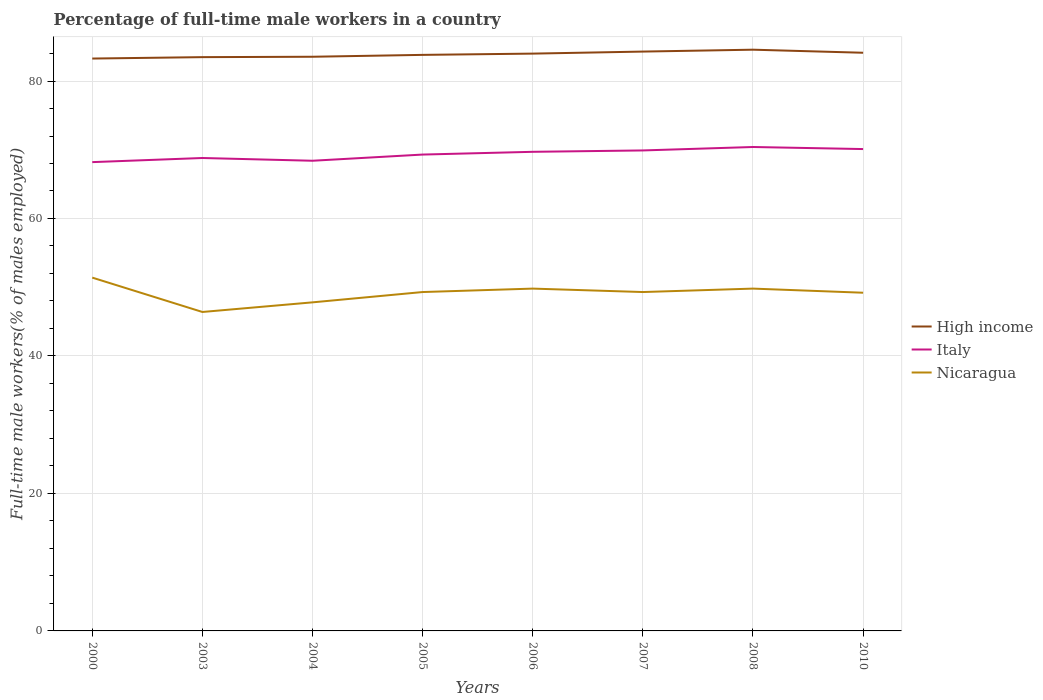Is the number of lines equal to the number of legend labels?
Provide a succinct answer. Yes. Across all years, what is the maximum percentage of full-time male workers in High income?
Give a very brief answer. 83.27. What is the total percentage of full-time male workers in Italy in the graph?
Ensure brevity in your answer.  -1.1. What is the difference between the highest and the second highest percentage of full-time male workers in Italy?
Offer a very short reply. 2.2. Is the percentage of full-time male workers in Italy strictly greater than the percentage of full-time male workers in Nicaragua over the years?
Provide a short and direct response. No. What is the difference between two consecutive major ticks on the Y-axis?
Your response must be concise. 20. Does the graph contain any zero values?
Provide a succinct answer. No. Does the graph contain grids?
Make the answer very short. Yes. How many legend labels are there?
Ensure brevity in your answer.  3. How are the legend labels stacked?
Your response must be concise. Vertical. What is the title of the graph?
Your answer should be very brief. Percentage of full-time male workers in a country. What is the label or title of the Y-axis?
Make the answer very short. Full-time male workers(% of males employed). What is the Full-time male workers(% of males employed) of High income in 2000?
Keep it short and to the point. 83.27. What is the Full-time male workers(% of males employed) in Italy in 2000?
Provide a succinct answer. 68.2. What is the Full-time male workers(% of males employed) in Nicaragua in 2000?
Give a very brief answer. 51.4. What is the Full-time male workers(% of males employed) of High income in 2003?
Ensure brevity in your answer.  83.47. What is the Full-time male workers(% of males employed) of Italy in 2003?
Your response must be concise. 68.8. What is the Full-time male workers(% of males employed) of Nicaragua in 2003?
Your response must be concise. 46.4. What is the Full-time male workers(% of males employed) of High income in 2004?
Ensure brevity in your answer.  83.53. What is the Full-time male workers(% of males employed) of Italy in 2004?
Offer a terse response. 68.4. What is the Full-time male workers(% of males employed) of Nicaragua in 2004?
Offer a very short reply. 47.8. What is the Full-time male workers(% of males employed) of High income in 2005?
Ensure brevity in your answer.  83.8. What is the Full-time male workers(% of males employed) in Italy in 2005?
Give a very brief answer. 69.3. What is the Full-time male workers(% of males employed) in Nicaragua in 2005?
Ensure brevity in your answer.  49.3. What is the Full-time male workers(% of males employed) in High income in 2006?
Offer a very short reply. 83.99. What is the Full-time male workers(% of males employed) of Italy in 2006?
Your response must be concise. 69.7. What is the Full-time male workers(% of males employed) of Nicaragua in 2006?
Offer a very short reply. 49.8. What is the Full-time male workers(% of males employed) in High income in 2007?
Your answer should be very brief. 84.28. What is the Full-time male workers(% of males employed) of Italy in 2007?
Keep it short and to the point. 69.9. What is the Full-time male workers(% of males employed) in Nicaragua in 2007?
Keep it short and to the point. 49.3. What is the Full-time male workers(% of males employed) in High income in 2008?
Give a very brief answer. 84.56. What is the Full-time male workers(% of males employed) of Italy in 2008?
Your response must be concise. 70.4. What is the Full-time male workers(% of males employed) in Nicaragua in 2008?
Provide a succinct answer. 49.8. What is the Full-time male workers(% of males employed) in High income in 2010?
Keep it short and to the point. 84.11. What is the Full-time male workers(% of males employed) of Italy in 2010?
Your answer should be very brief. 70.1. What is the Full-time male workers(% of males employed) in Nicaragua in 2010?
Ensure brevity in your answer.  49.2. Across all years, what is the maximum Full-time male workers(% of males employed) of High income?
Provide a short and direct response. 84.56. Across all years, what is the maximum Full-time male workers(% of males employed) of Italy?
Your response must be concise. 70.4. Across all years, what is the maximum Full-time male workers(% of males employed) in Nicaragua?
Provide a short and direct response. 51.4. Across all years, what is the minimum Full-time male workers(% of males employed) of High income?
Your answer should be very brief. 83.27. Across all years, what is the minimum Full-time male workers(% of males employed) of Italy?
Provide a succinct answer. 68.2. Across all years, what is the minimum Full-time male workers(% of males employed) of Nicaragua?
Offer a very short reply. 46.4. What is the total Full-time male workers(% of males employed) of High income in the graph?
Your answer should be compact. 671.01. What is the total Full-time male workers(% of males employed) of Italy in the graph?
Offer a terse response. 554.8. What is the total Full-time male workers(% of males employed) of Nicaragua in the graph?
Keep it short and to the point. 393. What is the difference between the Full-time male workers(% of males employed) in High income in 2000 and that in 2003?
Give a very brief answer. -0.2. What is the difference between the Full-time male workers(% of males employed) in High income in 2000 and that in 2004?
Ensure brevity in your answer.  -0.26. What is the difference between the Full-time male workers(% of males employed) in Italy in 2000 and that in 2004?
Your response must be concise. -0.2. What is the difference between the Full-time male workers(% of males employed) in Nicaragua in 2000 and that in 2004?
Your answer should be compact. 3.6. What is the difference between the Full-time male workers(% of males employed) of High income in 2000 and that in 2005?
Keep it short and to the point. -0.53. What is the difference between the Full-time male workers(% of males employed) in Italy in 2000 and that in 2005?
Your response must be concise. -1.1. What is the difference between the Full-time male workers(% of males employed) in Nicaragua in 2000 and that in 2005?
Offer a very short reply. 2.1. What is the difference between the Full-time male workers(% of males employed) of High income in 2000 and that in 2006?
Ensure brevity in your answer.  -0.72. What is the difference between the Full-time male workers(% of males employed) in Nicaragua in 2000 and that in 2006?
Offer a terse response. 1.6. What is the difference between the Full-time male workers(% of males employed) of High income in 2000 and that in 2007?
Your answer should be compact. -1.01. What is the difference between the Full-time male workers(% of males employed) of High income in 2000 and that in 2008?
Your answer should be very brief. -1.29. What is the difference between the Full-time male workers(% of males employed) in High income in 2000 and that in 2010?
Offer a terse response. -0.84. What is the difference between the Full-time male workers(% of males employed) of High income in 2003 and that in 2004?
Your answer should be compact. -0.06. What is the difference between the Full-time male workers(% of males employed) in Nicaragua in 2003 and that in 2004?
Provide a short and direct response. -1.4. What is the difference between the Full-time male workers(% of males employed) of High income in 2003 and that in 2005?
Your answer should be very brief. -0.33. What is the difference between the Full-time male workers(% of males employed) in Italy in 2003 and that in 2005?
Your answer should be compact. -0.5. What is the difference between the Full-time male workers(% of males employed) in Nicaragua in 2003 and that in 2005?
Your answer should be compact. -2.9. What is the difference between the Full-time male workers(% of males employed) in High income in 2003 and that in 2006?
Provide a short and direct response. -0.51. What is the difference between the Full-time male workers(% of males employed) in Italy in 2003 and that in 2006?
Your answer should be compact. -0.9. What is the difference between the Full-time male workers(% of males employed) of High income in 2003 and that in 2007?
Offer a very short reply. -0.81. What is the difference between the Full-time male workers(% of males employed) of Italy in 2003 and that in 2007?
Your response must be concise. -1.1. What is the difference between the Full-time male workers(% of males employed) in Nicaragua in 2003 and that in 2007?
Your answer should be compact. -2.9. What is the difference between the Full-time male workers(% of males employed) in High income in 2003 and that in 2008?
Ensure brevity in your answer.  -1.08. What is the difference between the Full-time male workers(% of males employed) in Italy in 2003 and that in 2008?
Your response must be concise. -1.6. What is the difference between the Full-time male workers(% of males employed) in High income in 2003 and that in 2010?
Your response must be concise. -0.64. What is the difference between the Full-time male workers(% of males employed) of Italy in 2003 and that in 2010?
Your answer should be very brief. -1.3. What is the difference between the Full-time male workers(% of males employed) in High income in 2004 and that in 2005?
Ensure brevity in your answer.  -0.27. What is the difference between the Full-time male workers(% of males employed) in Nicaragua in 2004 and that in 2005?
Provide a succinct answer. -1.5. What is the difference between the Full-time male workers(% of males employed) of High income in 2004 and that in 2006?
Ensure brevity in your answer.  -0.46. What is the difference between the Full-time male workers(% of males employed) in Nicaragua in 2004 and that in 2006?
Offer a terse response. -2. What is the difference between the Full-time male workers(% of males employed) of High income in 2004 and that in 2007?
Give a very brief answer. -0.75. What is the difference between the Full-time male workers(% of males employed) of Nicaragua in 2004 and that in 2007?
Provide a succinct answer. -1.5. What is the difference between the Full-time male workers(% of males employed) of High income in 2004 and that in 2008?
Make the answer very short. -1.03. What is the difference between the Full-time male workers(% of males employed) of Italy in 2004 and that in 2008?
Provide a short and direct response. -2. What is the difference between the Full-time male workers(% of males employed) of Nicaragua in 2004 and that in 2008?
Provide a succinct answer. -2. What is the difference between the Full-time male workers(% of males employed) of High income in 2004 and that in 2010?
Your answer should be compact. -0.58. What is the difference between the Full-time male workers(% of males employed) of Nicaragua in 2004 and that in 2010?
Make the answer very short. -1.4. What is the difference between the Full-time male workers(% of males employed) of High income in 2005 and that in 2006?
Make the answer very short. -0.19. What is the difference between the Full-time male workers(% of males employed) in High income in 2005 and that in 2007?
Provide a succinct answer. -0.48. What is the difference between the Full-time male workers(% of males employed) in High income in 2005 and that in 2008?
Ensure brevity in your answer.  -0.76. What is the difference between the Full-time male workers(% of males employed) in Nicaragua in 2005 and that in 2008?
Give a very brief answer. -0.5. What is the difference between the Full-time male workers(% of males employed) in High income in 2005 and that in 2010?
Ensure brevity in your answer.  -0.31. What is the difference between the Full-time male workers(% of males employed) in High income in 2006 and that in 2007?
Provide a short and direct response. -0.29. What is the difference between the Full-time male workers(% of males employed) in Italy in 2006 and that in 2007?
Give a very brief answer. -0.2. What is the difference between the Full-time male workers(% of males employed) of High income in 2006 and that in 2008?
Provide a short and direct response. -0.57. What is the difference between the Full-time male workers(% of males employed) of Italy in 2006 and that in 2008?
Your answer should be very brief. -0.7. What is the difference between the Full-time male workers(% of males employed) of Nicaragua in 2006 and that in 2008?
Give a very brief answer. 0. What is the difference between the Full-time male workers(% of males employed) in High income in 2006 and that in 2010?
Make the answer very short. -0.12. What is the difference between the Full-time male workers(% of males employed) in Italy in 2006 and that in 2010?
Your answer should be compact. -0.4. What is the difference between the Full-time male workers(% of males employed) of Nicaragua in 2006 and that in 2010?
Ensure brevity in your answer.  0.6. What is the difference between the Full-time male workers(% of males employed) of High income in 2007 and that in 2008?
Offer a very short reply. -0.28. What is the difference between the Full-time male workers(% of males employed) in High income in 2007 and that in 2010?
Offer a very short reply. 0.17. What is the difference between the Full-time male workers(% of males employed) of Italy in 2007 and that in 2010?
Your answer should be compact. -0.2. What is the difference between the Full-time male workers(% of males employed) in High income in 2008 and that in 2010?
Ensure brevity in your answer.  0.45. What is the difference between the Full-time male workers(% of males employed) of High income in 2000 and the Full-time male workers(% of males employed) of Italy in 2003?
Your response must be concise. 14.47. What is the difference between the Full-time male workers(% of males employed) in High income in 2000 and the Full-time male workers(% of males employed) in Nicaragua in 2003?
Provide a short and direct response. 36.87. What is the difference between the Full-time male workers(% of males employed) in Italy in 2000 and the Full-time male workers(% of males employed) in Nicaragua in 2003?
Offer a very short reply. 21.8. What is the difference between the Full-time male workers(% of males employed) of High income in 2000 and the Full-time male workers(% of males employed) of Italy in 2004?
Provide a succinct answer. 14.87. What is the difference between the Full-time male workers(% of males employed) of High income in 2000 and the Full-time male workers(% of males employed) of Nicaragua in 2004?
Provide a succinct answer. 35.47. What is the difference between the Full-time male workers(% of males employed) of Italy in 2000 and the Full-time male workers(% of males employed) of Nicaragua in 2004?
Provide a short and direct response. 20.4. What is the difference between the Full-time male workers(% of males employed) of High income in 2000 and the Full-time male workers(% of males employed) of Italy in 2005?
Offer a very short reply. 13.97. What is the difference between the Full-time male workers(% of males employed) of High income in 2000 and the Full-time male workers(% of males employed) of Nicaragua in 2005?
Keep it short and to the point. 33.97. What is the difference between the Full-time male workers(% of males employed) of High income in 2000 and the Full-time male workers(% of males employed) of Italy in 2006?
Make the answer very short. 13.57. What is the difference between the Full-time male workers(% of males employed) of High income in 2000 and the Full-time male workers(% of males employed) of Nicaragua in 2006?
Give a very brief answer. 33.47. What is the difference between the Full-time male workers(% of males employed) of High income in 2000 and the Full-time male workers(% of males employed) of Italy in 2007?
Provide a succinct answer. 13.37. What is the difference between the Full-time male workers(% of males employed) in High income in 2000 and the Full-time male workers(% of males employed) in Nicaragua in 2007?
Your answer should be compact. 33.97. What is the difference between the Full-time male workers(% of males employed) of Italy in 2000 and the Full-time male workers(% of males employed) of Nicaragua in 2007?
Provide a succinct answer. 18.9. What is the difference between the Full-time male workers(% of males employed) in High income in 2000 and the Full-time male workers(% of males employed) in Italy in 2008?
Your response must be concise. 12.87. What is the difference between the Full-time male workers(% of males employed) in High income in 2000 and the Full-time male workers(% of males employed) in Nicaragua in 2008?
Make the answer very short. 33.47. What is the difference between the Full-time male workers(% of males employed) of Italy in 2000 and the Full-time male workers(% of males employed) of Nicaragua in 2008?
Give a very brief answer. 18.4. What is the difference between the Full-time male workers(% of males employed) of High income in 2000 and the Full-time male workers(% of males employed) of Italy in 2010?
Provide a succinct answer. 13.17. What is the difference between the Full-time male workers(% of males employed) of High income in 2000 and the Full-time male workers(% of males employed) of Nicaragua in 2010?
Your response must be concise. 34.07. What is the difference between the Full-time male workers(% of males employed) in Italy in 2000 and the Full-time male workers(% of males employed) in Nicaragua in 2010?
Offer a very short reply. 19. What is the difference between the Full-time male workers(% of males employed) in High income in 2003 and the Full-time male workers(% of males employed) in Italy in 2004?
Give a very brief answer. 15.07. What is the difference between the Full-time male workers(% of males employed) of High income in 2003 and the Full-time male workers(% of males employed) of Nicaragua in 2004?
Offer a very short reply. 35.67. What is the difference between the Full-time male workers(% of males employed) in High income in 2003 and the Full-time male workers(% of males employed) in Italy in 2005?
Provide a short and direct response. 14.17. What is the difference between the Full-time male workers(% of males employed) in High income in 2003 and the Full-time male workers(% of males employed) in Nicaragua in 2005?
Provide a short and direct response. 34.17. What is the difference between the Full-time male workers(% of males employed) in High income in 2003 and the Full-time male workers(% of males employed) in Italy in 2006?
Offer a very short reply. 13.77. What is the difference between the Full-time male workers(% of males employed) of High income in 2003 and the Full-time male workers(% of males employed) of Nicaragua in 2006?
Your response must be concise. 33.67. What is the difference between the Full-time male workers(% of males employed) in High income in 2003 and the Full-time male workers(% of males employed) in Italy in 2007?
Your response must be concise. 13.57. What is the difference between the Full-time male workers(% of males employed) of High income in 2003 and the Full-time male workers(% of males employed) of Nicaragua in 2007?
Your response must be concise. 34.17. What is the difference between the Full-time male workers(% of males employed) in High income in 2003 and the Full-time male workers(% of males employed) in Italy in 2008?
Your answer should be compact. 13.07. What is the difference between the Full-time male workers(% of males employed) of High income in 2003 and the Full-time male workers(% of males employed) of Nicaragua in 2008?
Provide a succinct answer. 33.67. What is the difference between the Full-time male workers(% of males employed) of High income in 2003 and the Full-time male workers(% of males employed) of Italy in 2010?
Provide a short and direct response. 13.37. What is the difference between the Full-time male workers(% of males employed) in High income in 2003 and the Full-time male workers(% of males employed) in Nicaragua in 2010?
Keep it short and to the point. 34.27. What is the difference between the Full-time male workers(% of males employed) of Italy in 2003 and the Full-time male workers(% of males employed) of Nicaragua in 2010?
Provide a short and direct response. 19.6. What is the difference between the Full-time male workers(% of males employed) in High income in 2004 and the Full-time male workers(% of males employed) in Italy in 2005?
Offer a very short reply. 14.23. What is the difference between the Full-time male workers(% of males employed) of High income in 2004 and the Full-time male workers(% of males employed) of Nicaragua in 2005?
Offer a terse response. 34.23. What is the difference between the Full-time male workers(% of males employed) in Italy in 2004 and the Full-time male workers(% of males employed) in Nicaragua in 2005?
Give a very brief answer. 19.1. What is the difference between the Full-time male workers(% of males employed) of High income in 2004 and the Full-time male workers(% of males employed) of Italy in 2006?
Your answer should be compact. 13.83. What is the difference between the Full-time male workers(% of males employed) of High income in 2004 and the Full-time male workers(% of males employed) of Nicaragua in 2006?
Ensure brevity in your answer.  33.73. What is the difference between the Full-time male workers(% of males employed) of Italy in 2004 and the Full-time male workers(% of males employed) of Nicaragua in 2006?
Your response must be concise. 18.6. What is the difference between the Full-time male workers(% of males employed) in High income in 2004 and the Full-time male workers(% of males employed) in Italy in 2007?
Your response must be concise. 13.63. What is the difference between the Full-time male workers(% of males employed) of High income in 2004 and the Full-time male workers(% of males employed) of Nicaragua in 2007?
Provide a short and direct response. 34.23. What is the difference between the Full-time male workers(% of males employed) in Italy in 2004 and the Full-time male workers(% of males employed) in Nicaragua in 2007?
Offer a very short reply. 19.1. What is the difference between the Full-time male workers(% of males employed) in High income in 2004 and the Full-time male workers(% of males employed) in Italy in 2008?
Make the answer very short. 13.13. What is the difference between the Full-time male workers(% of males employed) in High income in 2004 and the Full-time male workers(% of males employed) in Nicaragua in 2008?
Offer a very short reply. 33.73. What is the difference between the Full-time male workers(% of males employed) of Italy in 2004 and the Full-time male workers(% of males employed) of Nicaragua in 2008?
Give a very brief answer. 18.6. What is the difference between the Full-time male workers(% of males employed) in High income in 2004 and the Full-time male workers(% of males employed) in Italy in 2010?
Offer a terse response. 13.43. What is the difference between the Full-time male workers(% of males employed) of High income in 2004 and the Full-time male workers(% of males employed) of Nicaragua in 2010?
Offer a very short reply. 34.33. What is the difference between the Full-time male workers(% of males employed) of Italy in 2004 and the Full-time male workers(% of males employed) of Nicaragua in 2010?
Offer a very short reply. 19.2. What is the difference between the Full-time male workers(% of males employed) of High income in 2005 and the Full-time male workers(% of males employed) of Italy in 2006?
Offer a very short reply. 14.1. What is the difference between the Full-time male workers(% of males employed) of High income in 2005 and the Full-time male workers(% of males employed) of Nicaragua in 2006?
Your response must be concise. 34. What is the difference between the Full-time male workers(% of males employed) of Italy in 2005 and the Full-time male workers(% of males employed) of Nicaragua in 2006?
Provide a short and direct response. 19.5. What is the difference between the Full-time male workers(% of males employed) in High income in 2005 and the Full-time male workers(% of males employed) in Italy in 2007?
Provide a short and direct response. 13.9. What is the difference between the Full-time male workers(% of males employed) of High income in 2005 and the Full-time male workers(% of males employed) of Nicaragua in 2007?
Offer a very short reply. 34.5. What is the difference between the Full-time male workers(% of males employed) of High income in 2005 and the Full-time male workers(% of males employed) of Italy in 2008?
Give a very brief answer. 13.4. What is the difference between the Full-time male workers(% of males employed) in High income in 2005 and the Full-time male workers(% of males employed) in Nicaragua in 2008?
Offer a terse response. 34. What is the difference between the Full-time male workers(% of males employed) in Italy in 2005 and the Full-time male workers(% of males employed) in Nicaragua in 2008?
Your answer should be compact. 19.5. What is the difference between the Full-time male workers(% of males employed) of High income in 2005 and the Full-time male workers(% of males employed) of Italy in 2010?
Provide a short and direct response. 13.7. What is the difference between the Full-time male workers(% of males employed) of High income in 2005 and the Full-time male workers(% of males employed) of Nicaragua in 2010?
Your answer should be compact. 34.6. What is the difference between the Full-time male workers(% of males employed) in Italy in 2005 and the Full-time male workers(% of males employed) in Nicaragua in 2010?
Offer a very short reply. 20.1. What is the difference between the Full-time male workers(% of males employed) in High income in 2006 and the Full-time male workers(% of males employed) in Italy in 2007?
Provide a succinct answer. 14.09. What is the difference between the Full-time male workers(% of males employed) in High income in 2006 and the Full-time male workers(% of males employed) in Nicaragua in 2007?
Make the answer very short. 34.69. What is the difference between the Full-time male workers(% of males employed) in Italy in 2006 and the Full-time male workers(% of males employed) in Nicaragua in 2007?
Offer a terse response. 20.4. What is the difference between the Full-time male workers(% of males employed) of High income in 2006 and the Full-time male workers(% of males employed) of Italy in 2008?
Your answer should be compact. 13.59. What is the difference between the Full-time male workers(% of males employed) in High income in 2006 and the Full-time male workers(% of males employed) in Nicaragua in 2008?
Your answer should be compact. 34.19. What is the difference between the Full-time male workers(% of males employed) of Italy in 2006 and the Full-time male workers(% of males employed) of Nicaragua in 2008?
Provide a short and direct response. 19.9. What is the difference between the Full-time male workers(% of males employed) of High income in 2006 and the Full-time male workers(% of males employed) of Italy in 2010?
Offer a terse response. 13.89. What is the difference between the Full-time male workers(% of males employed) of High income in 2006 and the Full-time male workers(% of males employed) of Nicaragua in 2010?
Provide a short and direct response. 34.79. What is the difference between the Full-time male workers(% of males employed) of Italy in 2006 and the Full-time male workers(% of males employed) of Nicaragua in 2010?
Provide a short and direct response. 20.5. What is the difference between the Full-time male workers(% of males employed) of High income in 2007 and the Full-time male workers(% of males employed) of Italy in 2008?
Your answer should be compact. 13.88. What is the difference between the Full-time male workers(% of males employed) in High income in 2007 and the Full-time male workers(% of males employed) in Nicaragua in 2008?
Make the answer very short. 34.48. What is the difference between the Full-time male workers(% of males employed) in Italy in 2007 and the Full-time male workers(% of males employed) in Nicaragua in 2008?
Give a very brief answer. 20.1. What is the difference between the Full-time male workers(% of males employed) in High income in 2007 and the Full-time male workers(% of males employed) in Italy in 2010?
Your answer should be compact. 14.18. What is the difference between the Full-time male workers(% of males employed) of High income in 2007 and the Full-time male workers(% of males employed) of Nicaragua in 2010?
Ensure brevity in your answer.  35.08. What is the difference between the Full-time male workers(% of males employed) of Italy in 2007 and the Full-time male workers(% of males employed) of Nicaragua in 2010?
Offer a very short reply. 20.7. What is the difference between the Full-time male workers(% of males employed) in High income in 2008 and the Full-time male workers(% of males employed) in Italy in 2010?
Give a very brief answer. 14.46. What is the difference between the Full-time male workers(% of males employed) in High income in 2008 and the Full-time male workers(% of males employed) in Nicaragua in 2010?
Give a very brief answer. 35.36. What is the difference between the Full-time male workers(% of males employed) of Italy in 2008 and the Full-time male workers(% of males employed) of Nicaragua in 2010?
Make the answer very short. 21.2. What is the average Full-time male workers(% of males employed) in High income per year?
Your answer should be very brief. 83.88. What is the average Full-time male workers(% of males employed) in Italy per year?
Keep it short and to the point. 69.35. What is the average Full-time male workers(% of males employed) in Nicaragua per year?
Offer a terse response. 49.12. In the year 2000, what is the difference between the Full-time male workers(% of males employed) of High income and Full-time male workers(% of males employed) of Italy?
Make the answer very short. 15.07. In the year 2000, what is the difference between the Full-time male workers(% of males employed) in High income and Full-time male workers(% of males employed) in Nicaragua?
Give a very brief answer. 31.87. In the year 2003, what is the difference between the Full-time male workers(% of males employed) in High income and Full-time male workers(% of males employed) in Italy?
Offer a terse response. 14.67. In the year 2003, what is the difference between the Full-time male workers(% of males employed) in High income and Full-time male workers(% of males employed) in Nicaragua?
Provide a succinct answer. 37.07. In the year 2003, what is the difference between the Full-time male workers(% of males employed) of Italy and Full-time male workers(% of males employed) of Nicaragua?
Give a very brief answer. 22.4. In the year 2004, what is the difference between the Full-time male workers(% of males employed) of High income and Full-time male workers(% of males employed) of Italy?
Ensure brevity in your answer.  15.13. In the year 2004, what is the difference between the Full-time male workers(% of males employed) of High income and Full-time male workers(% of males employed) of Nicaragua?
Give a very brief answer. 35.73. In the year 2004, what is the difference between the Full-time male workers(% of males employed) of Italy and Full-time male workers(% of males employed) of Nicaragua?
Keep it short and to the point. 20.6. In the year 2005, what is the difference between the Full-time male workers(% of males employed) of High income and Full-time male workers(% of males employed) of Italy?
Offer a terse response. 14.5. In the year 2005, what is the difference between the Full-time male workers(% of males employed) in High income and Full-time male workers(% of males employed) in Nicaragua?
Your response must be concise. 34.5. In the year 2006, what is the difference between the Full-time male workers(% of males employed) of High income and Full-time male workers(% of males employed) of Italy?
Your answer should be compact. 14.29. In the year 2006, what is the difference between the Full-time male workers(% of males employed) of High income and Full-time male workers(% of males employed) of Nicaragua?
Your answer should be compact. 34.19. In the year 2007, what is the difference between the Full-time male workers(% of males employed) in High income and Full-time male workers(% of males employed) in Italy?
Provide a succinct answer. 14.38. In the year 2007, what is the difference between the Full-time male workers(% of males employed) of High income and Full-time male workers(% of males employed) of Nicaragua?
Your answer should be very brief. 34.98. In the year 2007, what is the difference between the Full-time male workers(% of males employed) of Italy and Full-time male workers(% of males employed) of Nicaragua?
Give a very brief answer. 20.6. In the year 2008, what is the difference between the Full-time male workers(% of males employed) in High income and Full-time male workers(% of males employed) in Italy?
Offer a very short reply. 14.16. In the year 2008, what is the difference between the Full-time male workers(% of males employed) in High income and Full-time male workers(% of males employed) in Nicaragua?
Your answer should be compact. 34.76. In the year 2008, what is the difference between the Full-time male workers(% of males employed) in Italy and Full-time male workers(% of males employed) in Nicaragua?
Offer a very short reply. 20.6. In the year 2010, what is the difference between the Full-time male workers(% of males employed) of High income and Full-time male workers(% of males employed) of Italy?
Ensure brevity in your answer.  14.01. In the year 2010, what is the difference between the Full-time male workers(% of males employed) in High income and Full-time male workers(% of males employed) in Nicaragua?
Offer a terse response. 34.91. In the year 2010, what is the difference between the Full-time male workers(% of males employed) of Italy and Full-time male workers(% of males employed) of Nicaragua?
Your answer should be very brief. 20.9. What is the ratio of the Full-time male workers(% of males employed) of Italy in 2000 to that in 2003?
Your answer should be very brief. 0.99. What is the ratio of the Full-time male workers(% of males employed) in Nicaragua in 2000 to that in 2003?
Keep it short and to the point. 1.11. What is the ratio of the Full-time male workers(% of males employed) in High income in 2000 to that in 2004?
Offer a very short reply. 1. What is the ratio of the Full-time male workers(% of males employed) in Nicaragua in 2000 to that in 2004?
Ensure brevity in your answer.  1.08. What is the ratio of the Full-time male workers(% of males employed) in Italy in 2000 to that in 2005?
Provide a short and direct response. 0.98. What is the ratio of the Full-time male workers(% of males employed) in Nicaragua in 2000 to that in 2005?
Offer a very short reply. 1.04. What is the ratio of the Full-time male workers(% of males employed) of Italy in 2000 to that in 2006?
Give a very brief answer. 0.98. What is the ratio of the Full-time male workers(% of males employed) in Nicaragua in 2000 to that in 2006?
Provide a succinct answer. 1.03. What is the ratio of the Full-time male workers(% of males employed) of High income in 2000 to that in 2007?
Provide a succinct answer. 0.99. What is the ratio of the Full-time male workers(% of males employed) in Italy in 2000 to that in 2007?
Offer a very short reply. 0.98. What is the ratio of the Full-time male workers(% of males employed) in Nicaragua in 2000 to that in 2007?
Offer a very short reply. 1.04. What is the ratio of the Full-time male workers(% of males employed) of Italy in 2000 to that in 2008?
Your answer should be very brief. 0.97. What is the ratio of the Full-time male workers(% of males employed) of Nicaragua in 2000 to that in 2008?
Your response must be concise. 1.03. What is the ratio of the Full-time male workers(% of males employed) in High income in 2000 to that in 2010?
Your answer should be compact. 0.99. What is the ratio of the Full-time male workers(% of males employed) in Italy in 2000 to that in 2010?
Offer a terse response. 0.97. What is the ratio of the Full-time male workers(% of males employed) of Nicaragua in 2000 to that in 2010?
Offer a terse response. 1.04. What is the ratio of the Full-time male workers(% of males employed) of High income in 2003 to that in 2004?
Give a very brief answer. 1. What is the ratio of the Full-time male workers(% of males employed) of Italy in 2003 to that in 2004?
Give a very brief answer. 1.01. What is the ratio of the Full-time male workers(% of males employed) of Nicaragua in 2003 to that in 2004?
Keep it short and to the point. 0.97. What is the ratio of the Full-time male workers(% of males employed) in High income in 2003 to that in 2005?
Offer a terse response. 1. What is the ratio of the Full-time male workers(% of males employed) in Italy in 2003 to that in 2005?
Offer a very short reply. 0.99. What is the ratio of the Full-time male workers(% of males employed) of Nicaragua in 2003 to that in 2005?
Your answer should be compact. 0.94. What is the ratio of the Full-time male workers(% of males employed) in Italy in 2003 to that in 2006?
Provide a short and direct response. 0.99. What is the ratio of the Full-time male workers(% of males employed) of Nicaragua in 2003 to that in 2006?
Provide a short and direct response. 0.93. What is the ratio of the Full-time male workers(% of males employed) of High income in 2003 to that in 2007?
Your answer should be very brief. 0.99. What is the ratio of the Full-time male workers(% of males employed) in Italy in 2003 to that in 2007?
Keep it short and to the point. 0.98. What is the ratio of the Full-time male workers(% of males employed) of High income in 2003 to that in 2008?
Keep it short and to the point. 0.99. What is the ratio of the Full-time male workers(% of males employed) of Italy in 2003 to that in 2008?
Make the answer very short. 0.98. What is the ratio of the Full-time male workers(% of males employed) of Nicaragua in 2003 to that in 2008?
Provide a short and direct response. 0.93. What is the ratio of the Full-time male workers(% of males employed) in High income in 2003 to that in 2010?
Give a very brief answer. 0.99. What is the ratio of the Full-time male workers(% of males employed) of Italy in 2003 to that in 2010?
Keep it short and to the point. 0.98. What is the ratio of the Full-time male workers(% of males employed) in Nicaragua in 2003 to that in 2010?
Your answer should be compact. 0.94. What is the ratio of the Full-time male workers(% of males employed) of Nicaragua in 2004 to that in 2005?
Make the answer very short. 0.97. What is the ratio of the Full-time male workers(% of males employed) in Italy in 2004 to that in 2006?
Your answer should be very brief. 0.98. What is the ratio of the Full-time male workers(% of males employed) of Nicaragua in 2004 to that in 2006?
Ensure brevity in your answer.  0.96. What is the ratio of the Full-time male workers(% of males employed) of Italy in 2004 to that in 2007?
Provide a short and direct response. 0.98. What is the ratio of the Full-time male workers(% of males employed) of Nicaragua in 2004 to that in 2007?
Your response must be concise. 0.97. What is the ratio of the Full-time male workers(% of males employed) of Italy in 2004 to that in 2008?
Provide a succinct answer. 0.97. What is the ratio of the Full-time male workers(% of males employed) in Nicaragua in 2004 to that in 2008?
Your answer should be very brief. 0.96. What is the ratio of the Full-time male workers(% of males employed) in High income in 2004 to that in 2010?
Give a very brief answer. 0.99. What is the ratio of the Full-time male workers(% of males employed) of Italy in 2004 to that in 2010?
Provide a short and direct response. 0.98. What is the ratio of the Full-time male workers(% of males employed) of Nicaragua in 2004 to that in 2010?
Your response must be concise. 0.97. What is the ratio of the Full-time male workers(% of males employed) of High income in 2005 to that in 2006?
Provide a succinct answer. 1. What is the ratio of the Full-time male workers(% of males employed) in Italy in 2005 to that in 2006?
Keep it short and to the point. 0.99. What is the ratio of the Full-time male workers(% of males employed) of Italy in 2005 to that in 2007?
Provide a succinct answer. 0.99. What is the ratio of the Full-time male workers(% of males employed) of High income in 2005 to that in 2008?
Provide a succinct answer. 0.99. What is the ratio of the Full-time male workers(% of males employed) in Italy in 2005 to that in 2008?
Your response must be concise. 0.98. What is the ratio of the Full-time male workers(% of males employed) of Nicaragua in 2005 to that in 2008?
Provide a short and direct response. 0.99. What is the ratio of the Full-time male workers(% of males employed) of High income in 2005 to that in 2010?
Offer a terse response. 1. What is the ratio of the Full-time male workers(% of males employed) in Italy in 2005 to that in 2010?
Offer a very short reply. 0.99. What is the ratio of the Full-time male workers(% of males employed) in Nicaragua in 2005 to that in 2010?
Provide a succinct answer. 1. What is the ratio of the Full-time male workers(% of males employed) of High income in 2006 to that in 2007?
Offer a terse response. 1. What is the ratio of the Full-time male workers(% of males employed) of Nicaragua in 2006 to that in 2007?
Provide a short and direct response. 1.01. What is the ratio of the Full-time male workers(% of males employed) of Italy in 2006 to that in 2008?
Offer a terse response. 0.99. What is the ratio of the Full-time male workers(% of males employed) in Nicaragua in 2006 to that in 2010?
Make the answer very short. 1.01. What is the ratio of the Full-time male workers(% of males employed) in High income in 2007 to that in 2008?
Your answer should be compact. 1. What is the ratio of the Full-time male workers(% of males employed) in Italy in 2007 to that in 2008?
Your answer should be very brief. 0.99. What is the ratio of the Full-time male workers(% of males employed) in Italy in 2007 to that in 2010?
Ensure brevity in your answer.  1. What is the ratio of the Full-time male workers(% of males employed) in Nicaragua in 2007 to that in 2010?
Provide a short and direct response. 1. What is the ratio of the Full-time male workers(% of males employed) of Nicaragua in 2008 to that in 2010?
Make the answer very short. 1.01. What is the difference between the highest and the second highest Full-time male workers(% of males employed) in High income?
Keep it short and to the point. 0.28. What is the difference between the highest and the second highest Full-time male workers(% of males employed) of Nicaragua?
Your answer should be compact. 1.6. What is the difference between the highest and the lowest Full-time male workers(% of males employed) in High income?
Offer a very short reply. 1.29. What is the difference between the highest and the lowest Full-time male workers(% of males employed) in Italy?
Your answer should be very brief. 2.2. 